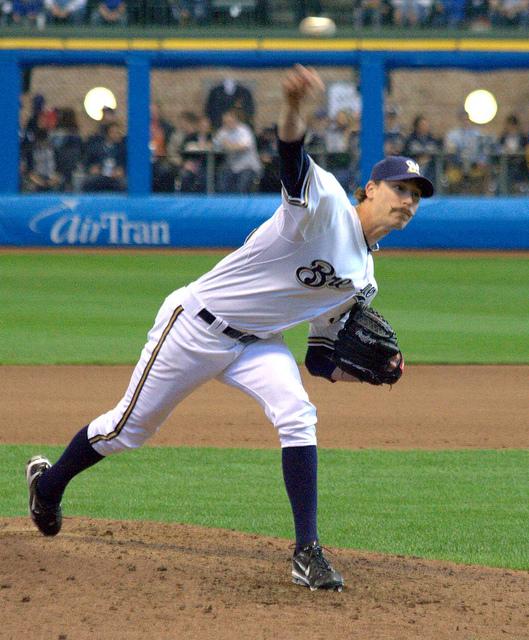What position does he play?
Keep it brief. Pitcher. What does the wall say behind the pitcher?
Answer briefly. Airtran. Is this man part of the St. Louis Cardinals?
Keep it brief. No. 